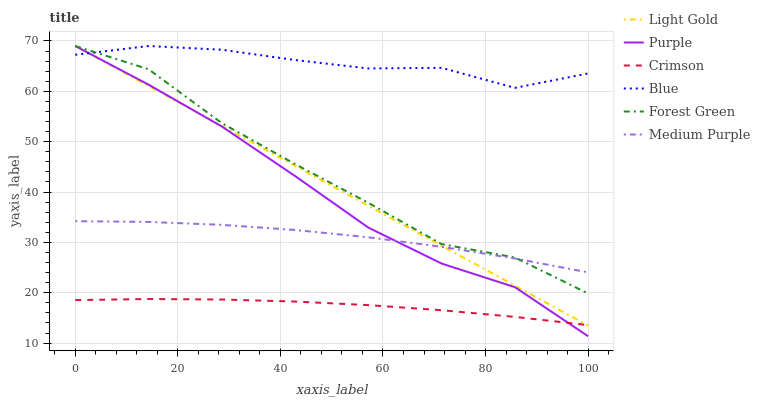Does Crimson have the minimum area under the curve?
Answer yes or no. Yes. Does Blue have the maximum area under the curve?
Answer yes or no. Yes. Does Purple have the minimum area under the curve?
Answer yes or no. No. Does Purple have the maximum area under the curve?
Answer yes or no. No. Is Light Gold the smoothest?
Answer yes or no. Yes. Is Forest Green the roughest?
Answer yes or no. Yes. Is Purple the smoothest?
Answer yes or no. No. Is Purple the roughest?
Answer yes or no. No. Does Purple have the lowest value?
Answer yes or no. Yes. Does Medium Purple have the lowest value?
Answer yes or no. No. Does Light Gold have the highest value?
Answer yes or no. Yes. Does Medium Purple have the highest value?
Answer yes or no. No. Is Crimson less than Medium Purple?
Answer yes or no. Yes. Is Medium Purple greater than Crimson?
Answer yes or no. Yes. Does Light Gold intersect Crimson?
Answer yes or no. Yes. Is Light Gold less than Crimson?
Answer yes or no. No. Is Light Gold greater than Crimson?
Answer yes or no. No. Does Crimson intersect Medium Purple?
Answer yes or no. No. 